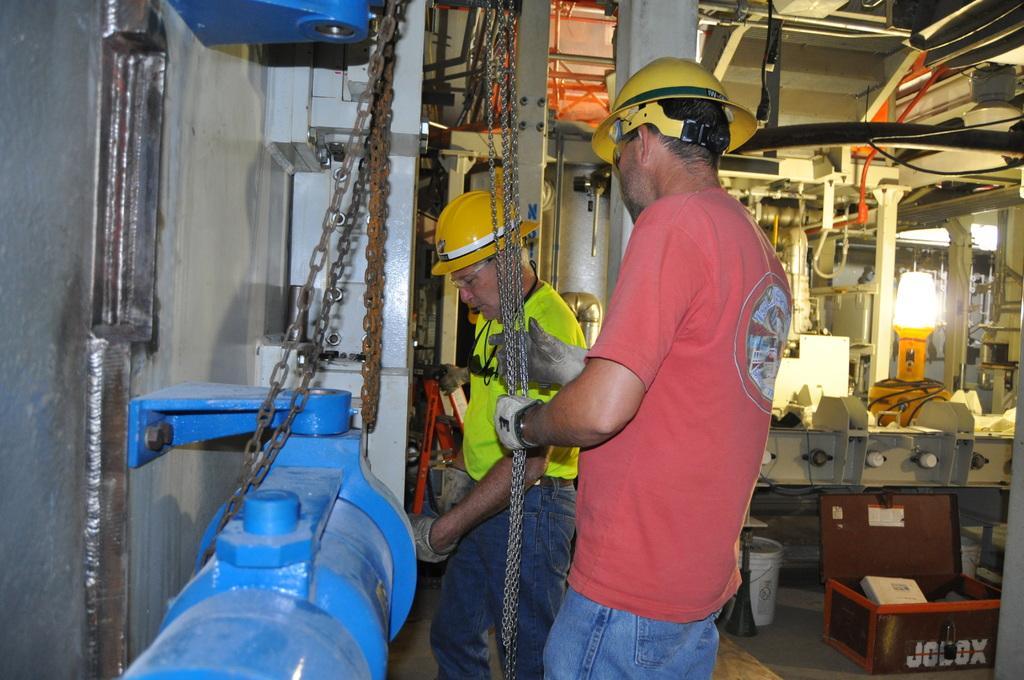Could you give a brief overview of what you see in this image? In this image we can see two men standing on the floor wearing the helmets. In that a person is holding the chains. We can also see a metal device tied with the chains. On the right side we can see a container and a bucket on the floor, some electrical devices, a light and some poles. 